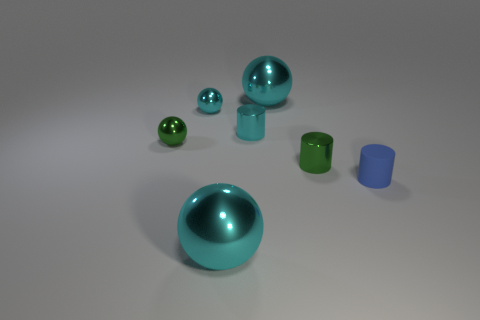Subtract all brown blocks. How many cyan balls are left? 3 Subtract all green balls. How many balls are left? 3 Subtract all green spheres. How many spheres are left? 3 Add 2 cyan cylinders. How many objects exist? 9 Subtract all blue spheres. Subtract all purple cylinders. How many spheres are left? 4 Subtract all spheres. How many objects are left? 3 Subtract all tiny brown rubber balls. Subtract all small shiny objects. How many objects are left? 3 Add 2 green metallic balls. How many green metallic balls are left? 3 Add 7 blue metal balls. How many blue metal balls exist? 7 Subtract 0 brown blocks. How many objects are left? 7 